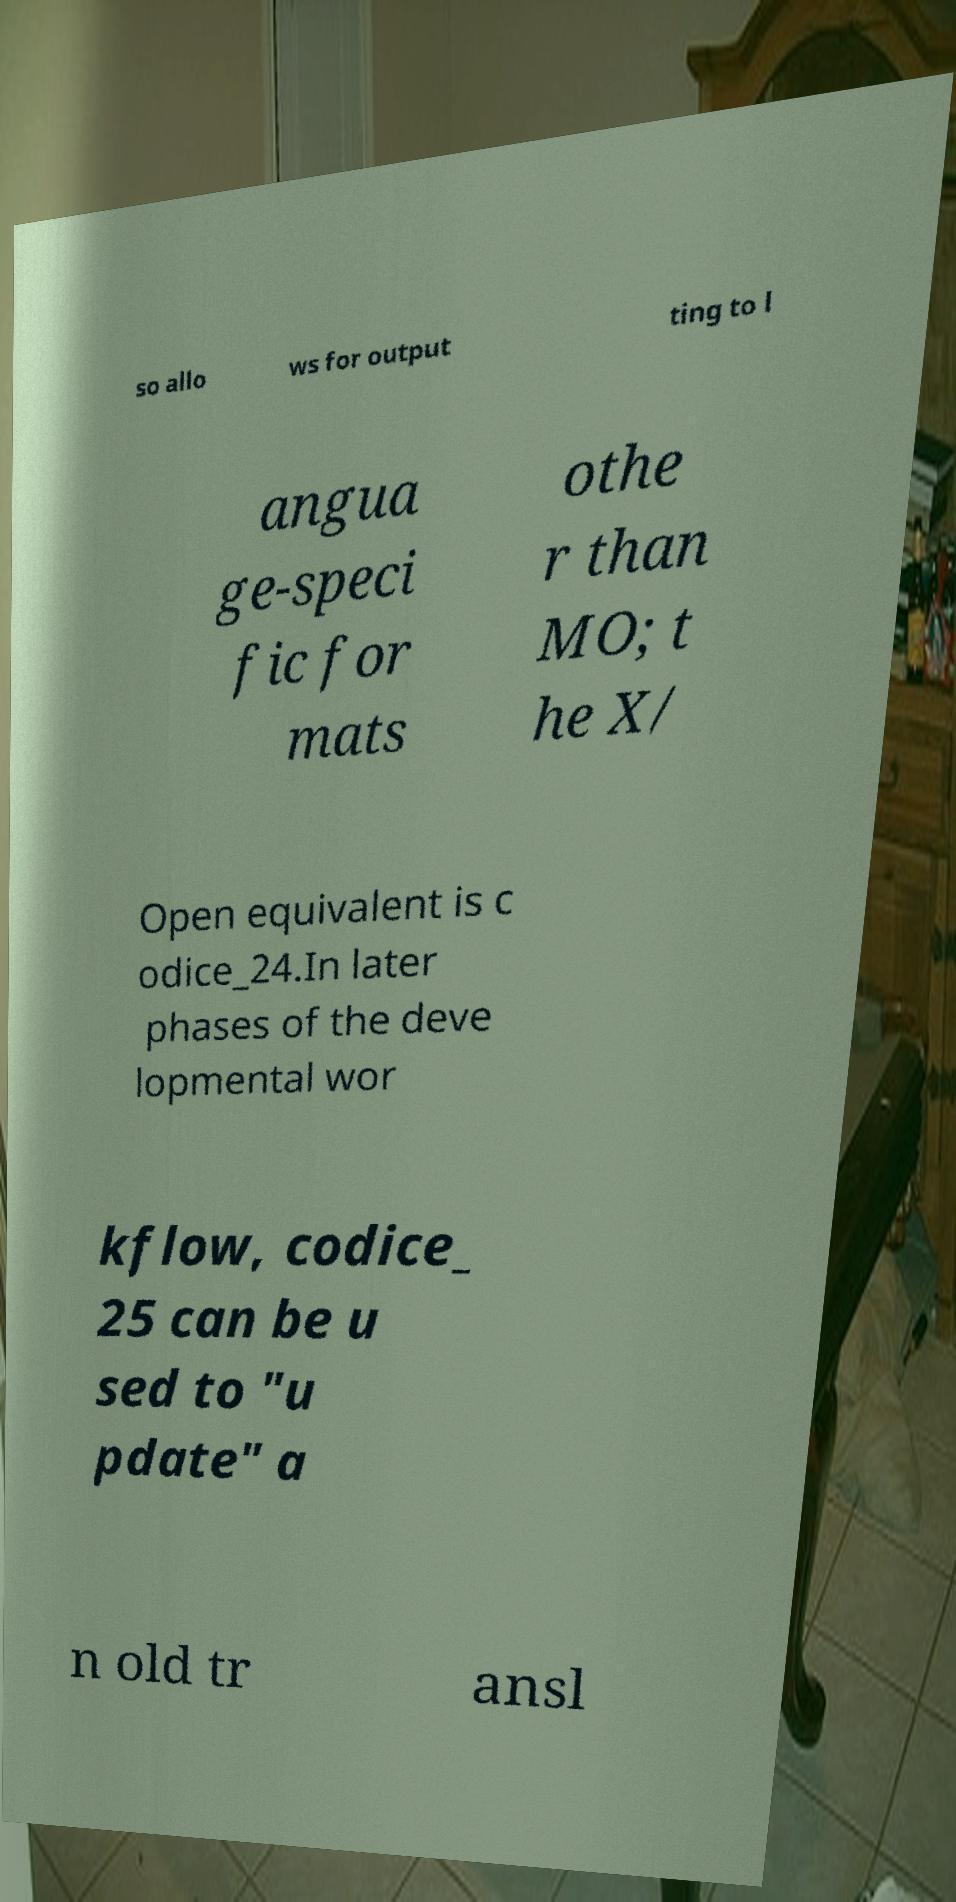I need the written content from this picture converted into text. Can you do that? so allo ws for output ting to l angua ge-speci fic for mats othe r than MO; t he X/ Open equivalent is c odice_24.In later phases of the deve lopmental wor kflow, codice_ 25 can be u sed to "u pdate" a n old tr ansl 